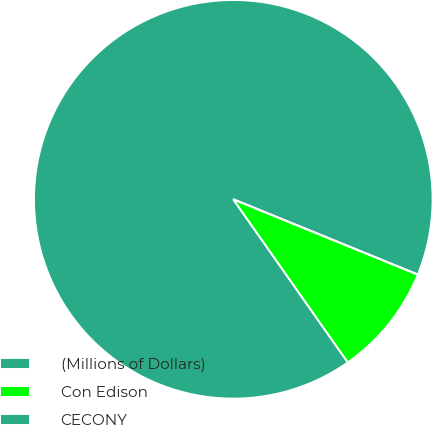Convert chart. <chart><loc_0><loc_0><loc_500><loc_500><pie_chart><fcel>(Millions of Dollars)<fcel>Con Edison<fcel>CECONY<nl><fcel>90.91%<fcel>9.09%<fcel>0.0%<nl></chart> 